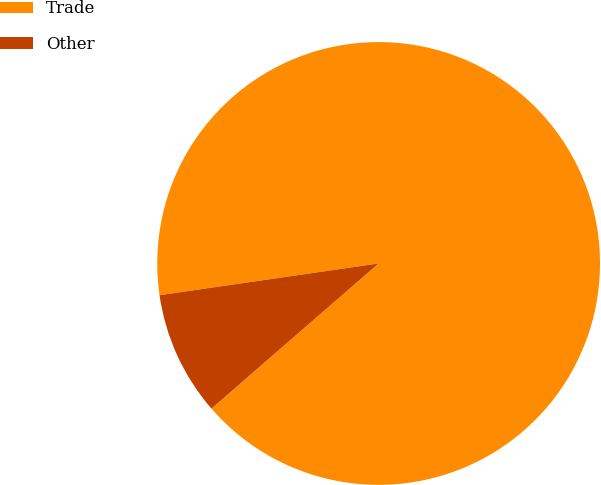<chart> <loc_0><loc_0><loc_500><loc_500><pie_chart><fcel>Trade<fcel>Other<nl><fcel>90.91%<fcel>9.09%<nl></chart> 